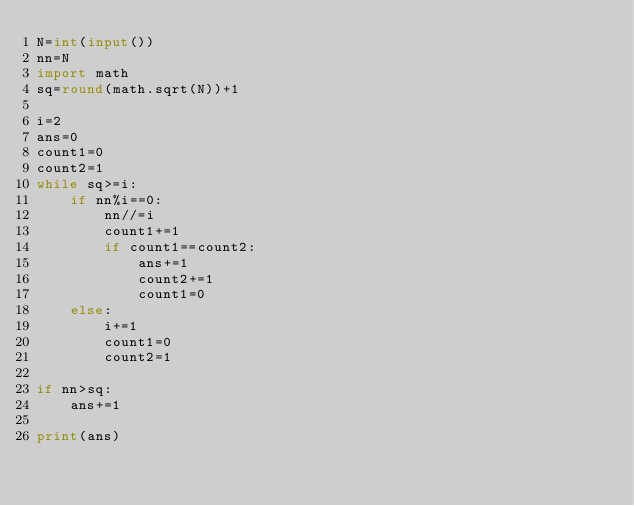Convert code to text. <code><loc_0><loc_0><loc_500><loc_500><_Python_>N=int(input())
nn=N
import math
sq=round(math.sqrt(N))+1

i=2
ans=0
count1=0
count2=1
while sq>=i:
    if nn%i==0:
        nn//=i
        count1+=1
        if count1==count2:
            ans+=1
            count2+=1
            count1=0
    else:
        i+=1
        count1=0
        count2=1

if nn>sq:
    ans+=1

print(ans)</code> 